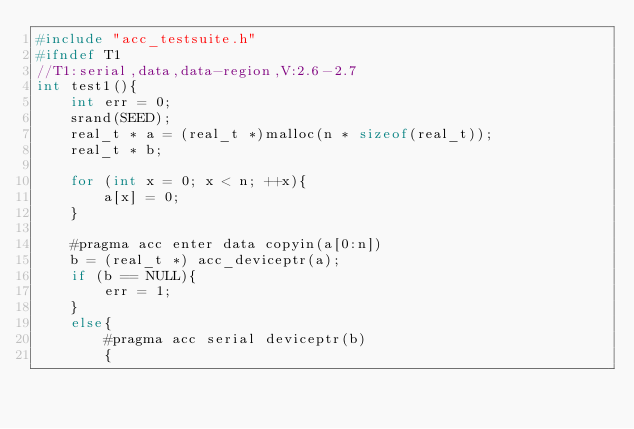Convert code to text. <code><loc_0><loc_0><loc_500><loc_500><_C_>#include "acc_testsuite.h"
#ifndef T1
//T1:serial,data,data-region,V:2.6-2.7
int test1(){
    int err = 0;
    srand(SEED);
    real_t * a = (real_t *)malloc(n * sizeof(real_t));
    real_t * b;

    for (int x = 0; x < n; ++x){
        a[x] = 0;
    }

    #pragma acc enter data copyin(a[0:n])
    b = (real_t *) acc_deviceptr(a);
    if (b == NULL){
        err = 1;
    }
    else{
        #pragma acc serial deviceptr(b)
        {</code> 